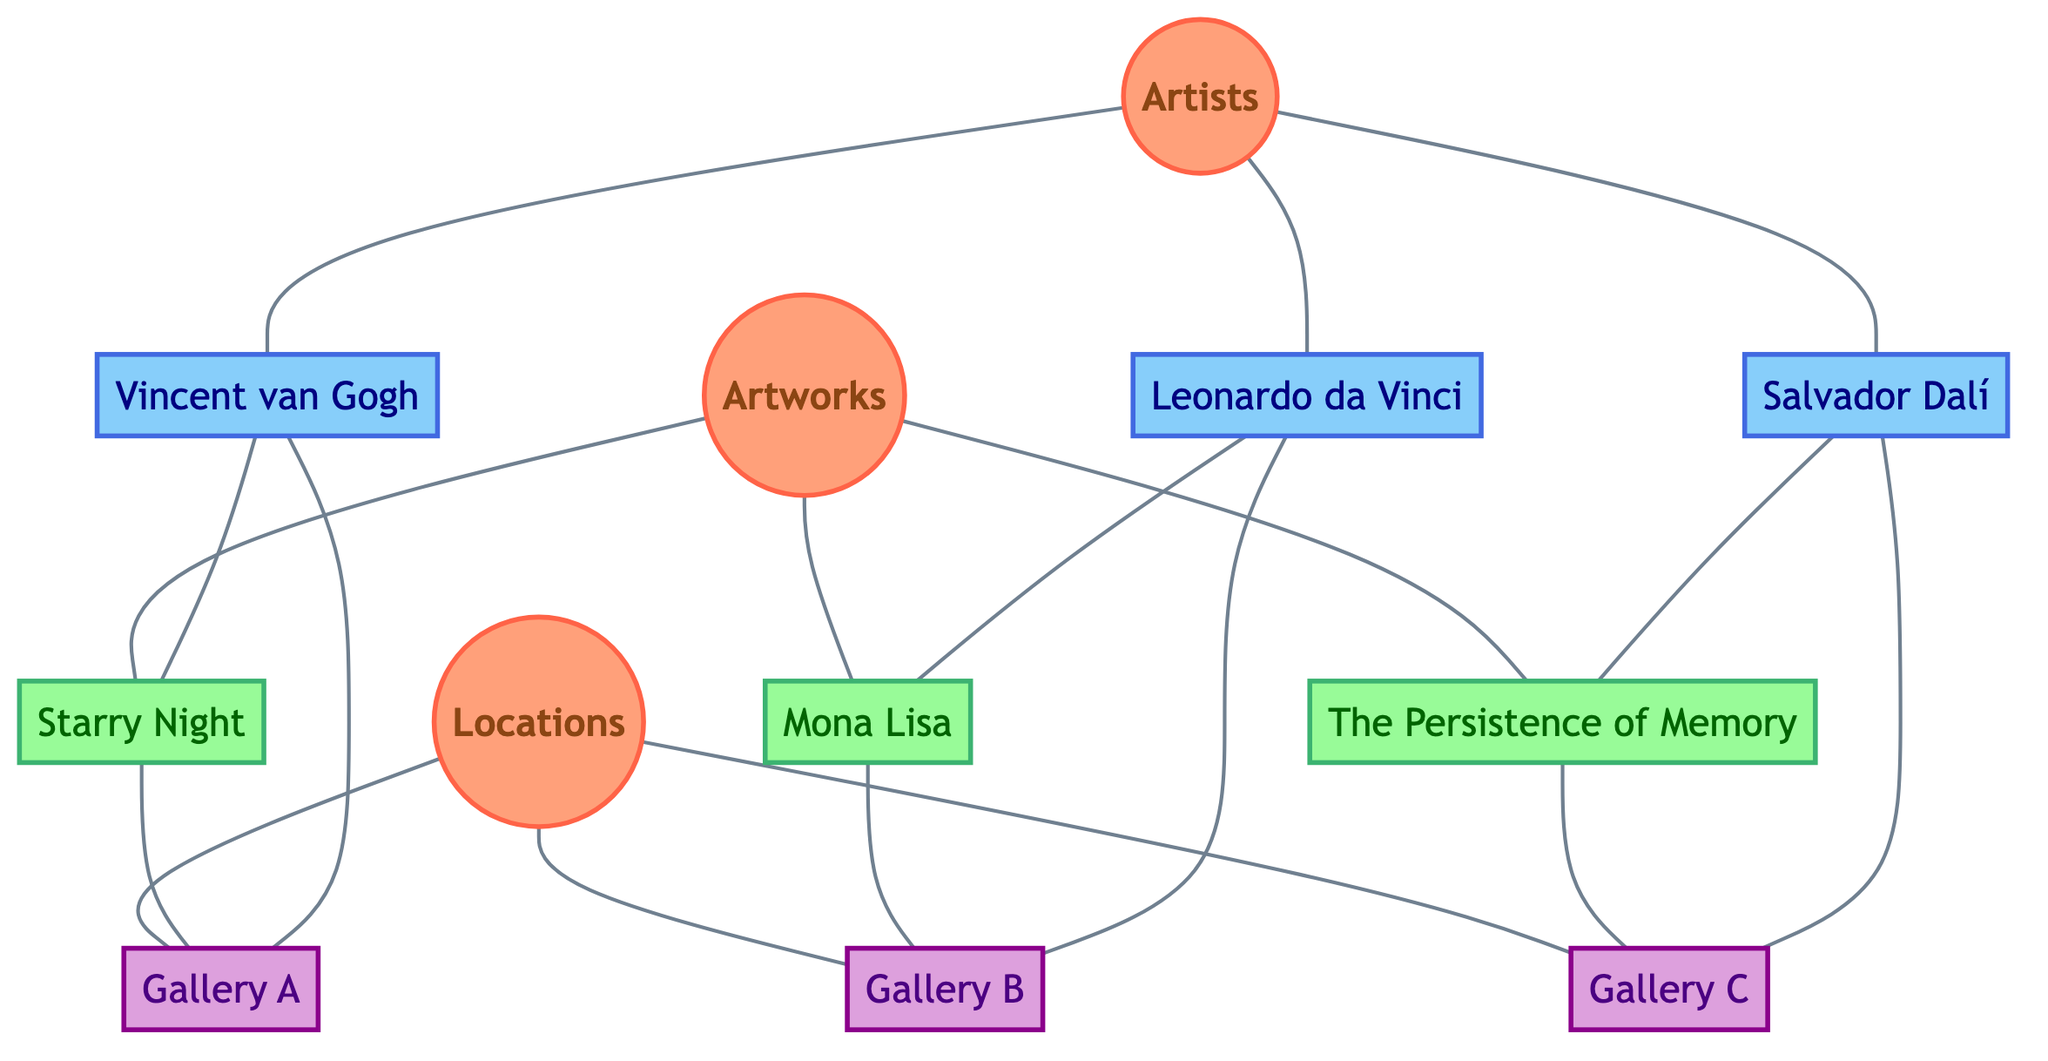What artworks are listed in the diagram? The diagram lists three artworks: Starry Night, Mona Lisa, and The Persistence of Memory. Each of these is a direct connection from the Artworks node.
Answer: Starry Night, Mona Lisa, The Persistence of Memory Who is the artist of Starry Night? The diagram shows that Vincent van Gogh is connected to Starry Night, indicating he is the artist of this work.
Answer: Vincent van Gogh How many locations are shown in the diagram? The diagram indicates there are three locations connected to the Locations node: Gallery A, Gallery B, and Gallery C. This can be counted directly from the connections.
Answer: 3 Which artist has artwork displayed at Gallery B? By examining the edges, it can be seen that the Mona Lisa, which is associated with Leonardo da Vinci, is displayed at Gallery B.
Answer: Mona Lisa Which artwork is associated with Salvador Dalí? In the diagram, The Persistence of Memory is directly linked to Salvador Dalí, indicating this is his artwork.
Answer: The Persistence of Memory How many edges are connected to the Artists node? The Artists node has three edges connected to it, each leading to a different artist: Vincent van Gogh, Leonardo da Vinci, and Salvador Dalí.
Answer: 3 At which gallery is The Persistence of Memory located? According to the edges, The Persistence of Memory is connected to Gallery C, indicating this is its location.
Answer: Gallery C Which artist has a direct connection to Gallery A? The diagram shows that both Vincent van Gogh and Starry Night are directly connected to Gallery A. Therefore, Vincent van Gogh is the artist with a direct connection to this gallery.
Answer: Vincent van Gogh What type of graph is illustrated in the diagram? The diagram is an undirected graph, as it showcases relationships without indicating directionality among the nodes involved, meaning relationships flow both ways.
Answer: Undirected Graph 